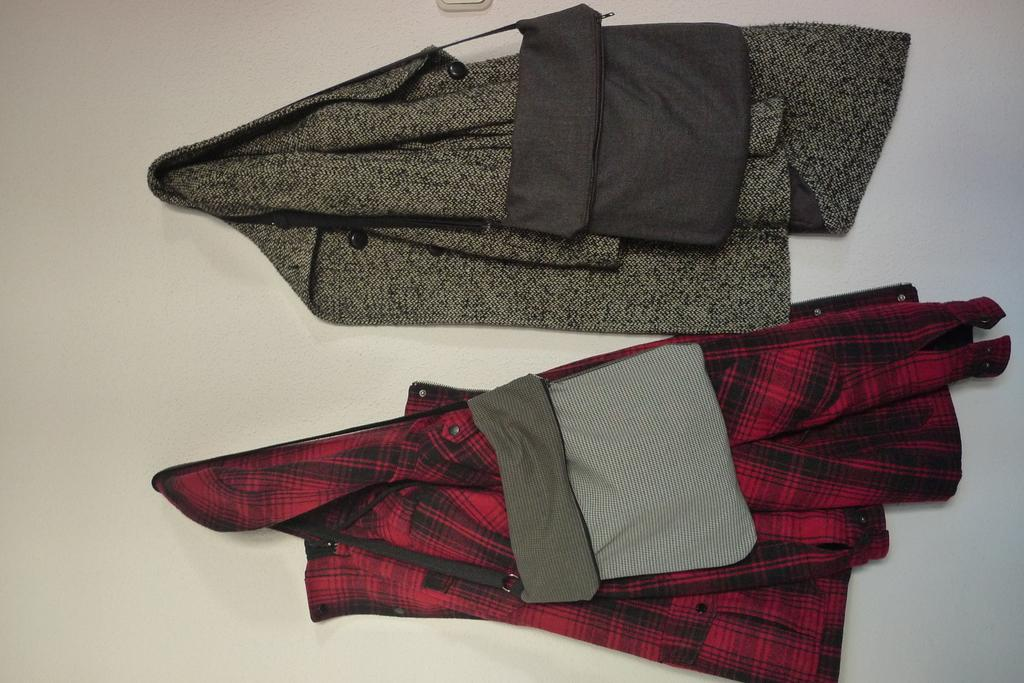What type of clothing items are in the image? There are two shirts in the image. How are the shirts positioned in the image? The shirts are hanging on a wall. What other items are hanging on the wall in the image? There are two bags hanging on the wall in the image. What type of thought is expressed by the shirts in the image? There is no thought expressed by the shirts in the image, as they are inanimate objects. Are there any slaves depicted in the image? There is no mention of slaves or any related context in the image. 